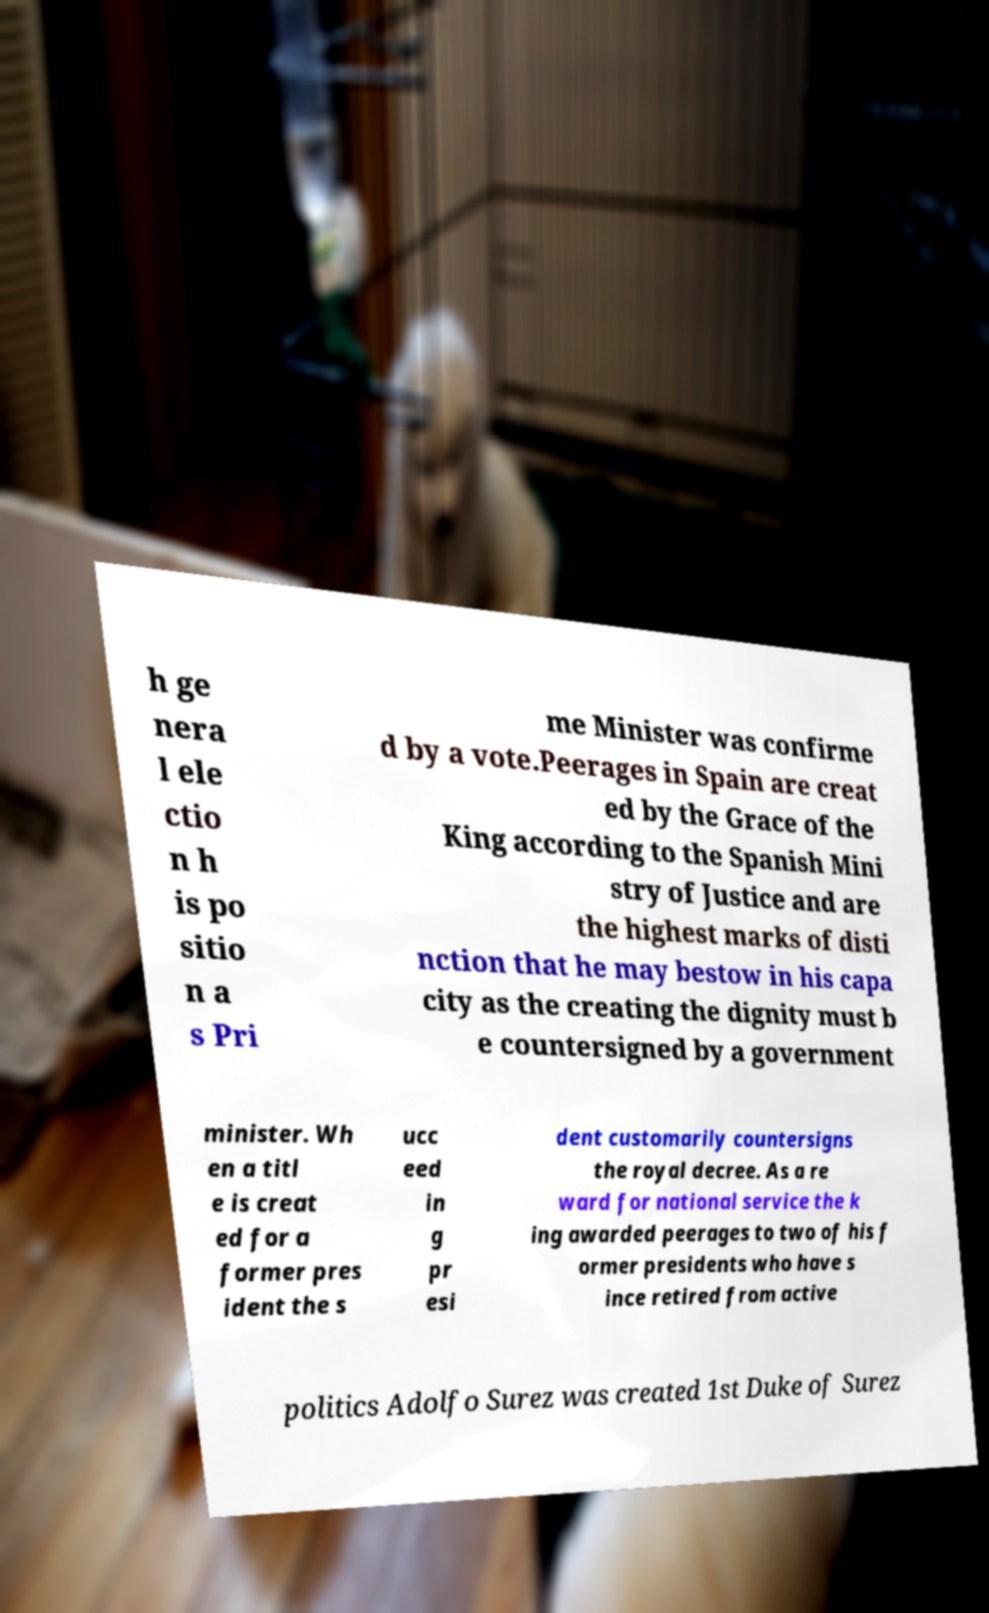Could you extract and type out the text from this image? h ge nera l ele ctio n h is po sitio n a s Pri me Minister was confirme d by a vote.Peerages in Spain are creat ed by the Grace of the King according to the Spanish Mini stry of Justice and are the highest marks of disti nction that he may bestow in his capa city as the creating the dignity must b e countersigned by a government minister. Wh en a titl e is creat ed for a former pres ident the s ucc eed in g pr esi dent customarily countersigns the royal decree. As a re ward for national service the k ing awarded peerages to two of his f ormer presidents who have s ince retired from active politics Adolfo Surez was created 1st Duke of Surez 